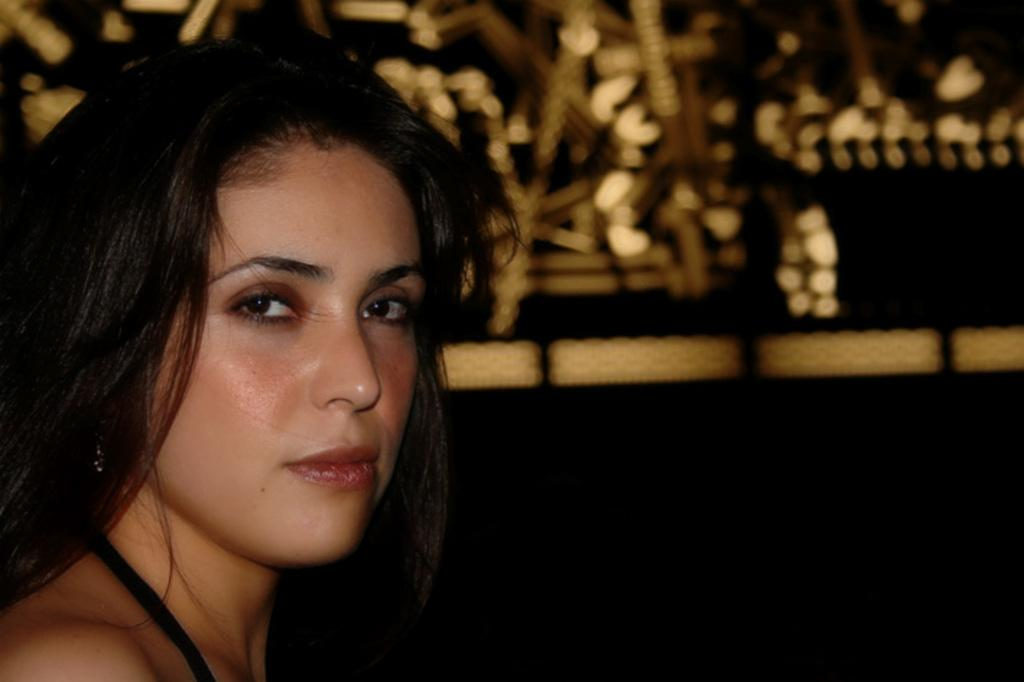Who is the main subject in the image? There is a woman in the image. Can you describe the background of the image? The background of the image is blurry. What type of business is the woman operating in the image? There is no indication of a business in the image; it only features a woman and a blurry background. 